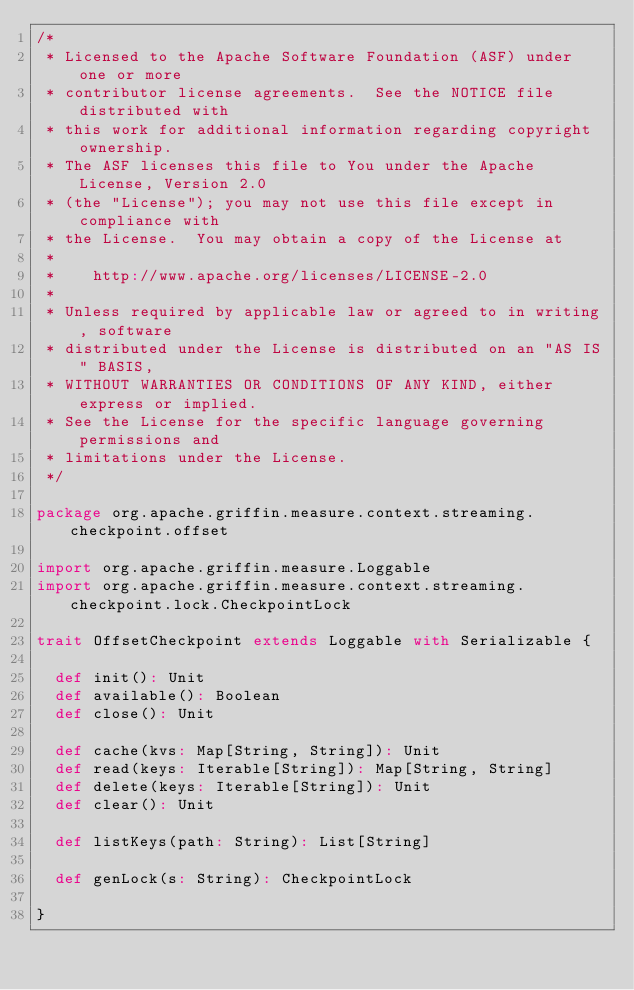Convert code to text. <code><loc_0><loc_0><loc_500><loc_500><_Scala_>/*
 * Licensed to the Apache Software Foundation (ASF) under one or more
 * contributor license agreements.  See the NOTICE file distributed with
 * this work for additional information regarding copyright ownership.
 * The ASF licenses this file to You under the Apache License, Version 2.0
 * (the "License"); you may not use this file except in compliance with
 * the License.  You may obtain a copy of the License at
 *
 *    http://www.apache.org/licenses/LICENSE-2.0
 *
 * Unless required by applicable law or agreed to in writing, software
 * distributed under the License is distributed on an "AS IS" BASIS,
 * WITHOUT WARRANTIES OR CONDITIONS OF ANY KIND, either express or implied.
 * See the License for the specific language governing permissions and
 * limitations under the License.
 */

package org.apache.griffin.measure.context.streaming.checkpoint.offset

import org.apache.griffin.measure.Loggable
import org.apache.griffin.measure.context.streaming.checkpoint.lock.CheckpointLock

trait OffsetCheckpoint extends Loggable with Serializable {

  def init(): Unit
  def available(): Boolean
  def close(): Unit

  def cache(kvs: Map[String, String]): Unit
  def read(keys: Iterable[String]): Map[String, String]
  def delete(keys: Iterable[String]): Unit
  def clear(): Unit

  def listKeys(path: String): List[String]

  def genLock(s: String): CheckpointLock

}
</code> 